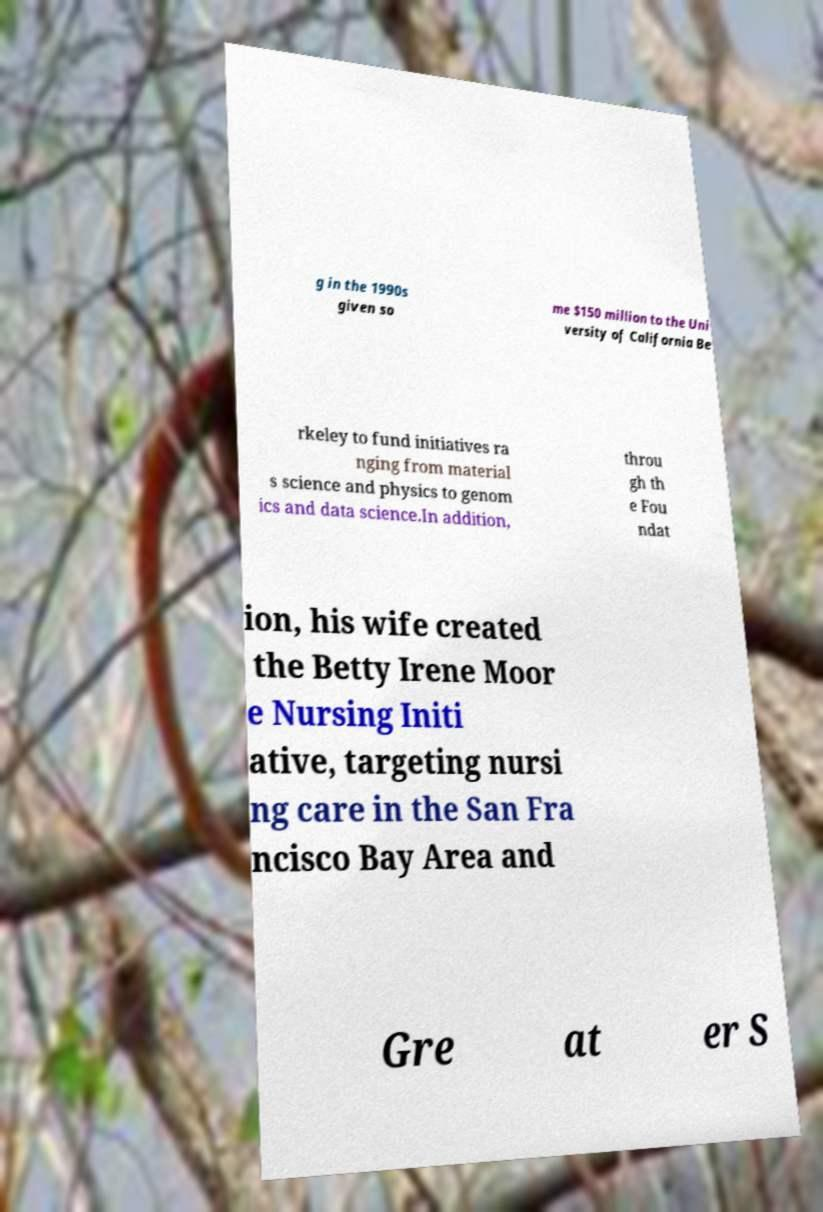Please read and relay the text visible in this image. What does it say? g in the 1990s given so me $150 million to the Uni versity of California Be rkeley to fund initiatives ra nging from material s science and physics to genom ics and data science.In addition, throu gh th e Fou ndat ion, his wife created the Betty Irene Moor e Nursing Initi ative, targeting nursi ng care in the San Fra ncisco Bay Area and Gre at er S 